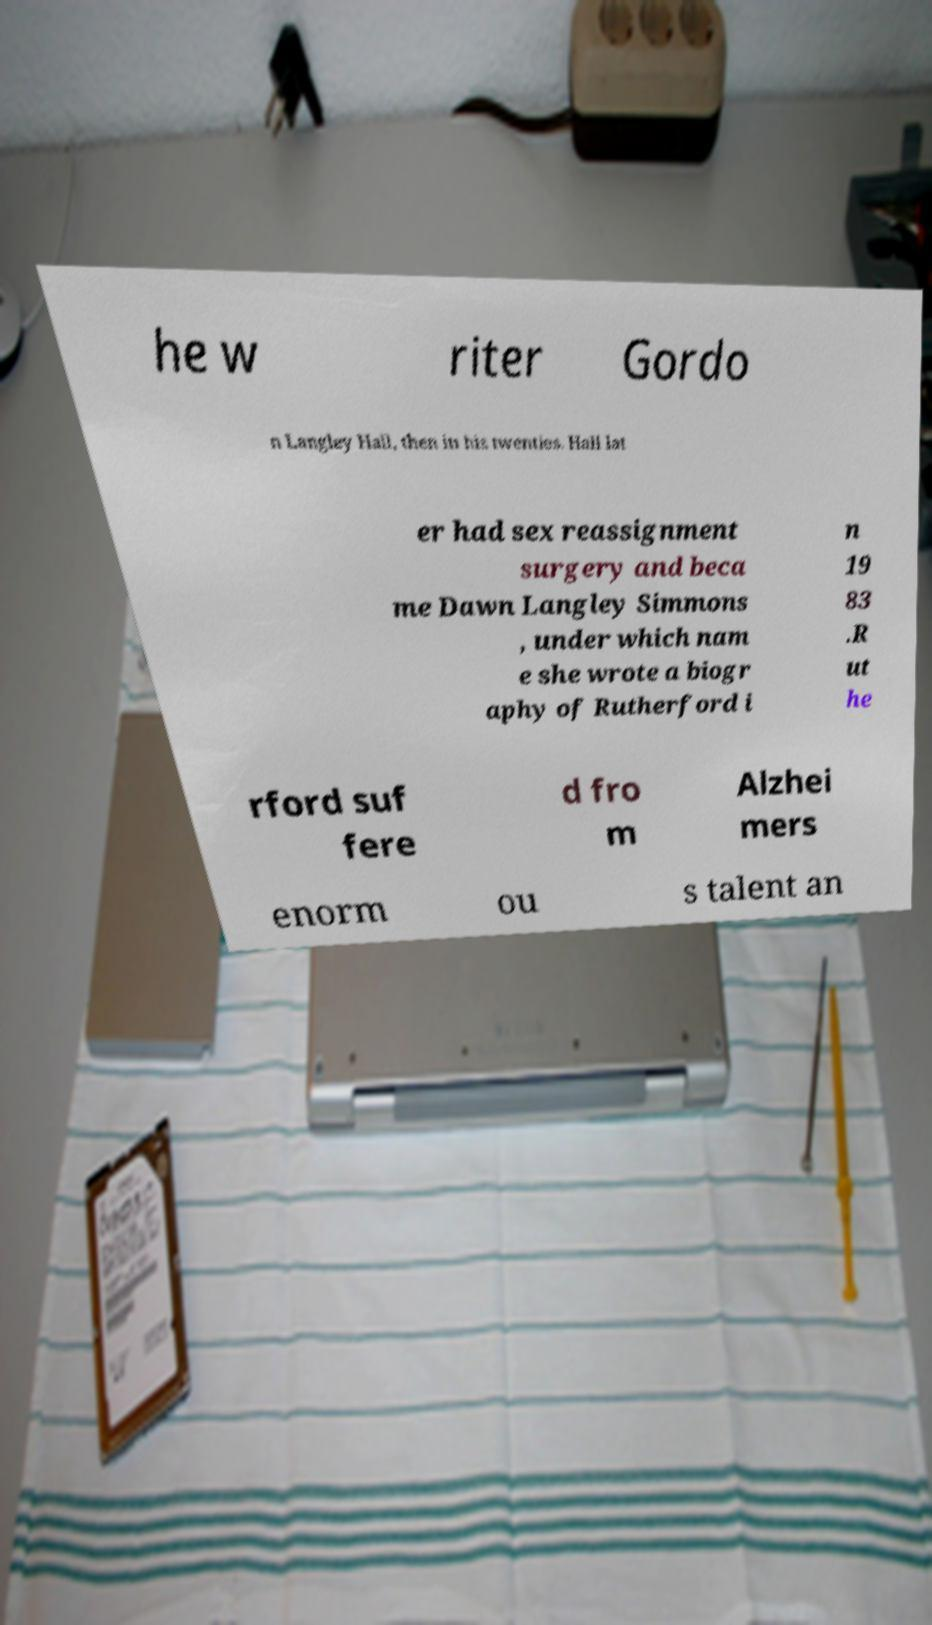For documentation purposes, I need the text within this image transcribed. Could you provide that? he w riter Gordo n Langley Hall, then in his twenties. Hall lat er had sex reassignment surgery and beca me Dawn Langley Simmons , under which nam e she wrote a biogr aphy of Rutherford i n 19 83 .R ut he rford suf fere d fro m Alzhei mers enorm ou s talent an 